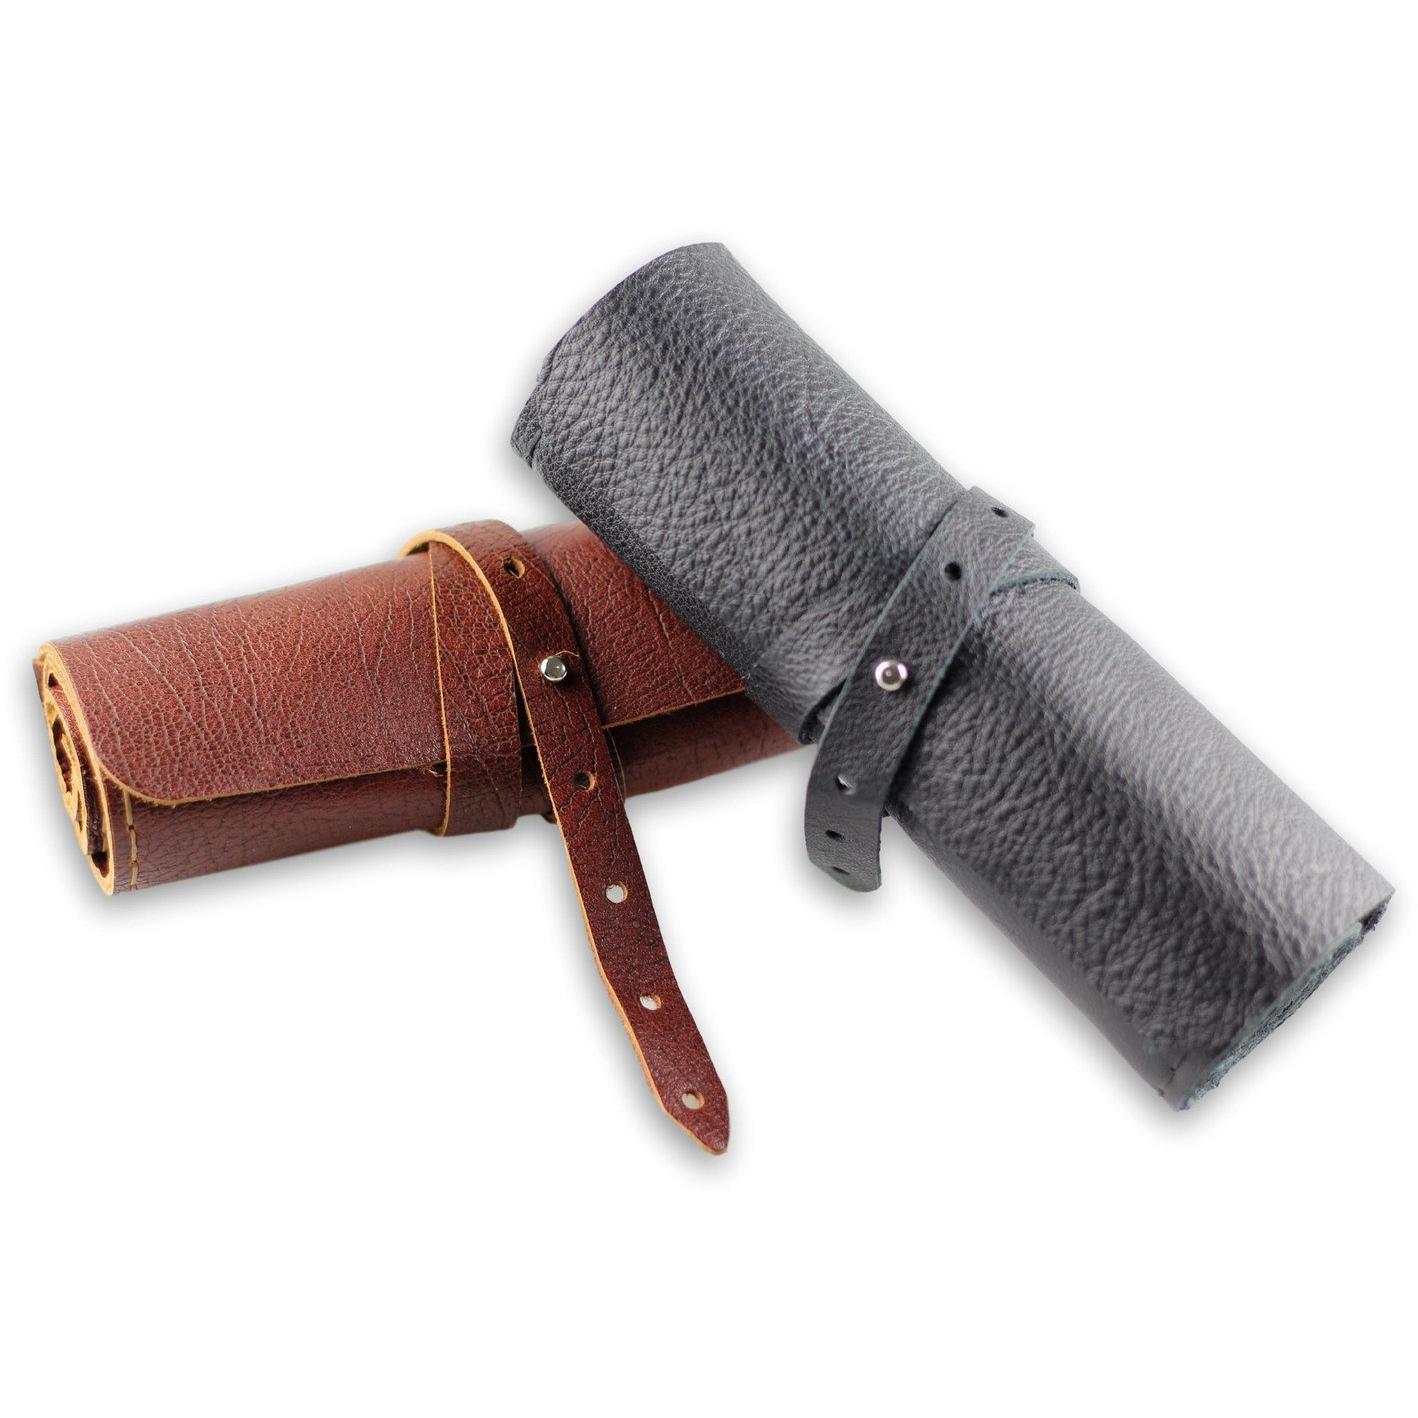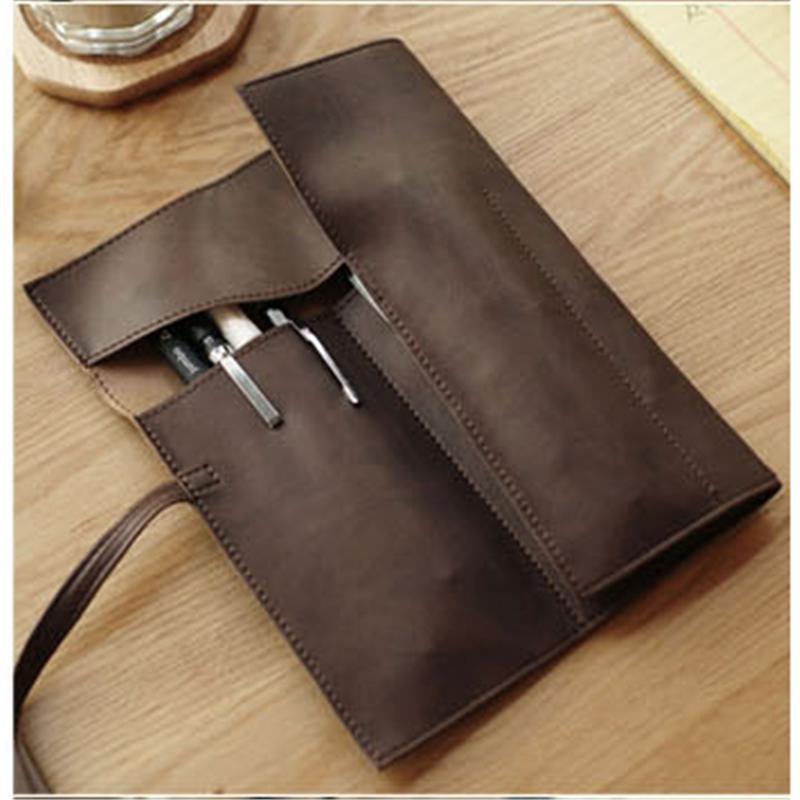The first image is the image on the left, the second image is the image on the right. Given the left and right images, does the statement "One image includes an opened pink case filled with writing implements." hold true? Answer yes or no. No. The first image is the image on the left, the second image is the image on the right. Evaluate the accuracy of this statement regarding the images: "Two pink pencil cases sit next to each other in the image on the right.". Is it true? Answer yes or no. No. 